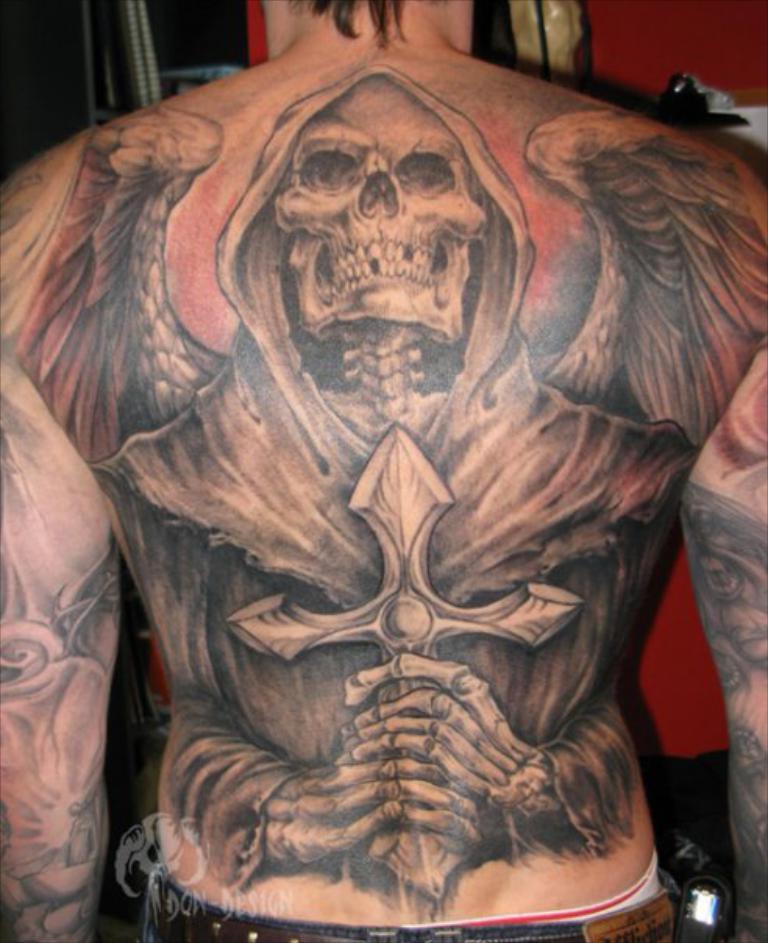Describe this image in one or two sentences. In this image we can see the tattoo on the body of a person. In the background we can see the wall and also an object. At the bottom we can see the logo and also the text. 